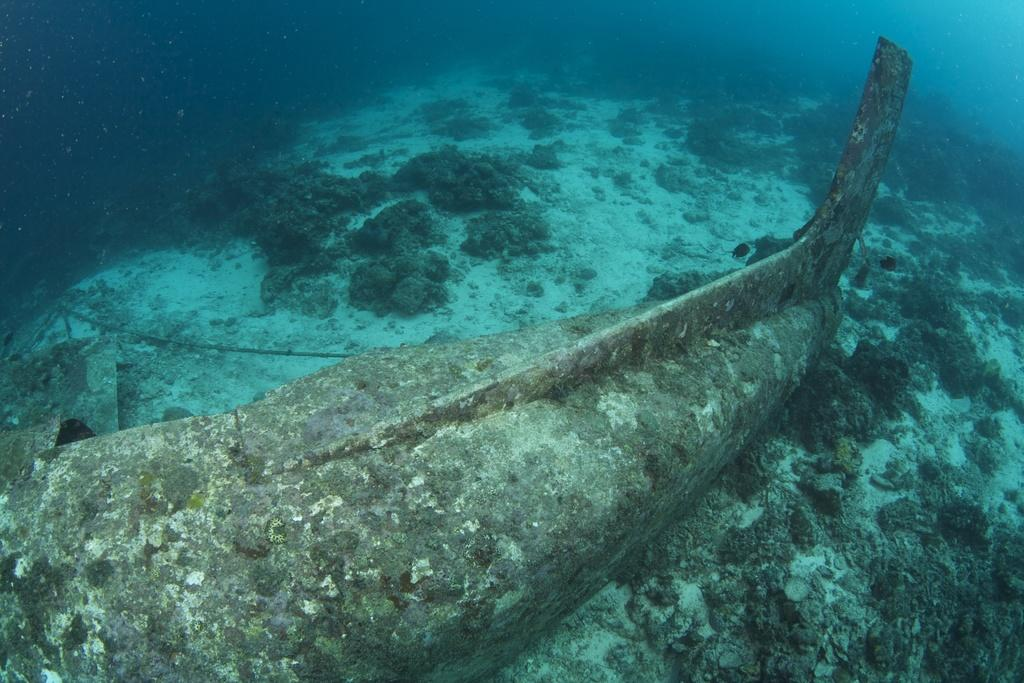What is the setting of the image? The image is underwater. What type of landscape can be seen in the image? There is a plain visible in the image. What is on the ground in the image? There are stones on the ground in the image. What type of cord is used to connect the park to the motion detector in the image? There is no park, cord, or motion detector present in the image; it is an underwater scene with a plain and stones. 